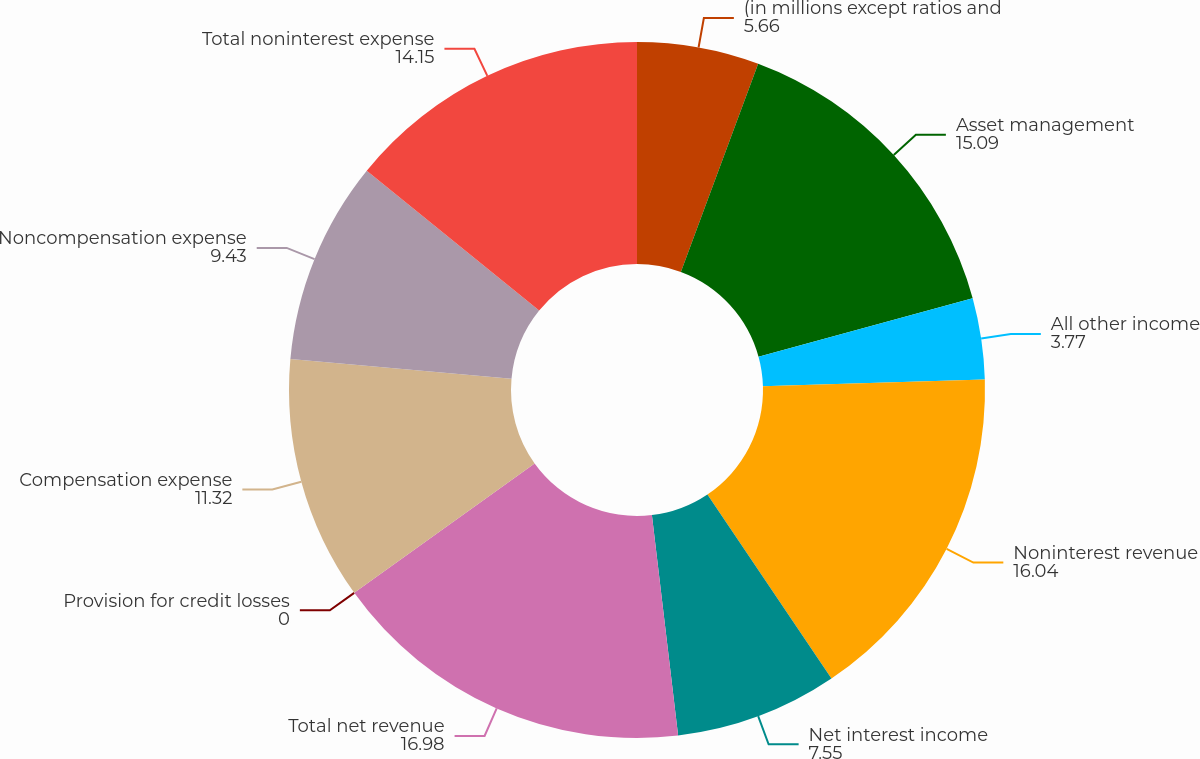Convert chart. <chart><loc_0><loc_0><loc_500><loc_500><pie_chart><fcel>(in millions except ratios and<fcel>Asset management<fcel>All other income<fcel>Noninterest revenue<fcel>Net interest income<fcel>Total net revenue<fcel>Provision for credit losses<fcel>Compensation expense<fcel>Noncompensation expense<fcel>Total noninterest expense<nl><fcel>5.66%<fcel>15.09%<fcel>3.77%<fcel>16.04%<fcel>7.55%<fcel>16.98%<fcel>0.0%<fcel>11.32%<fcel>9.43%<fcel>14.15%<nl></chart> 